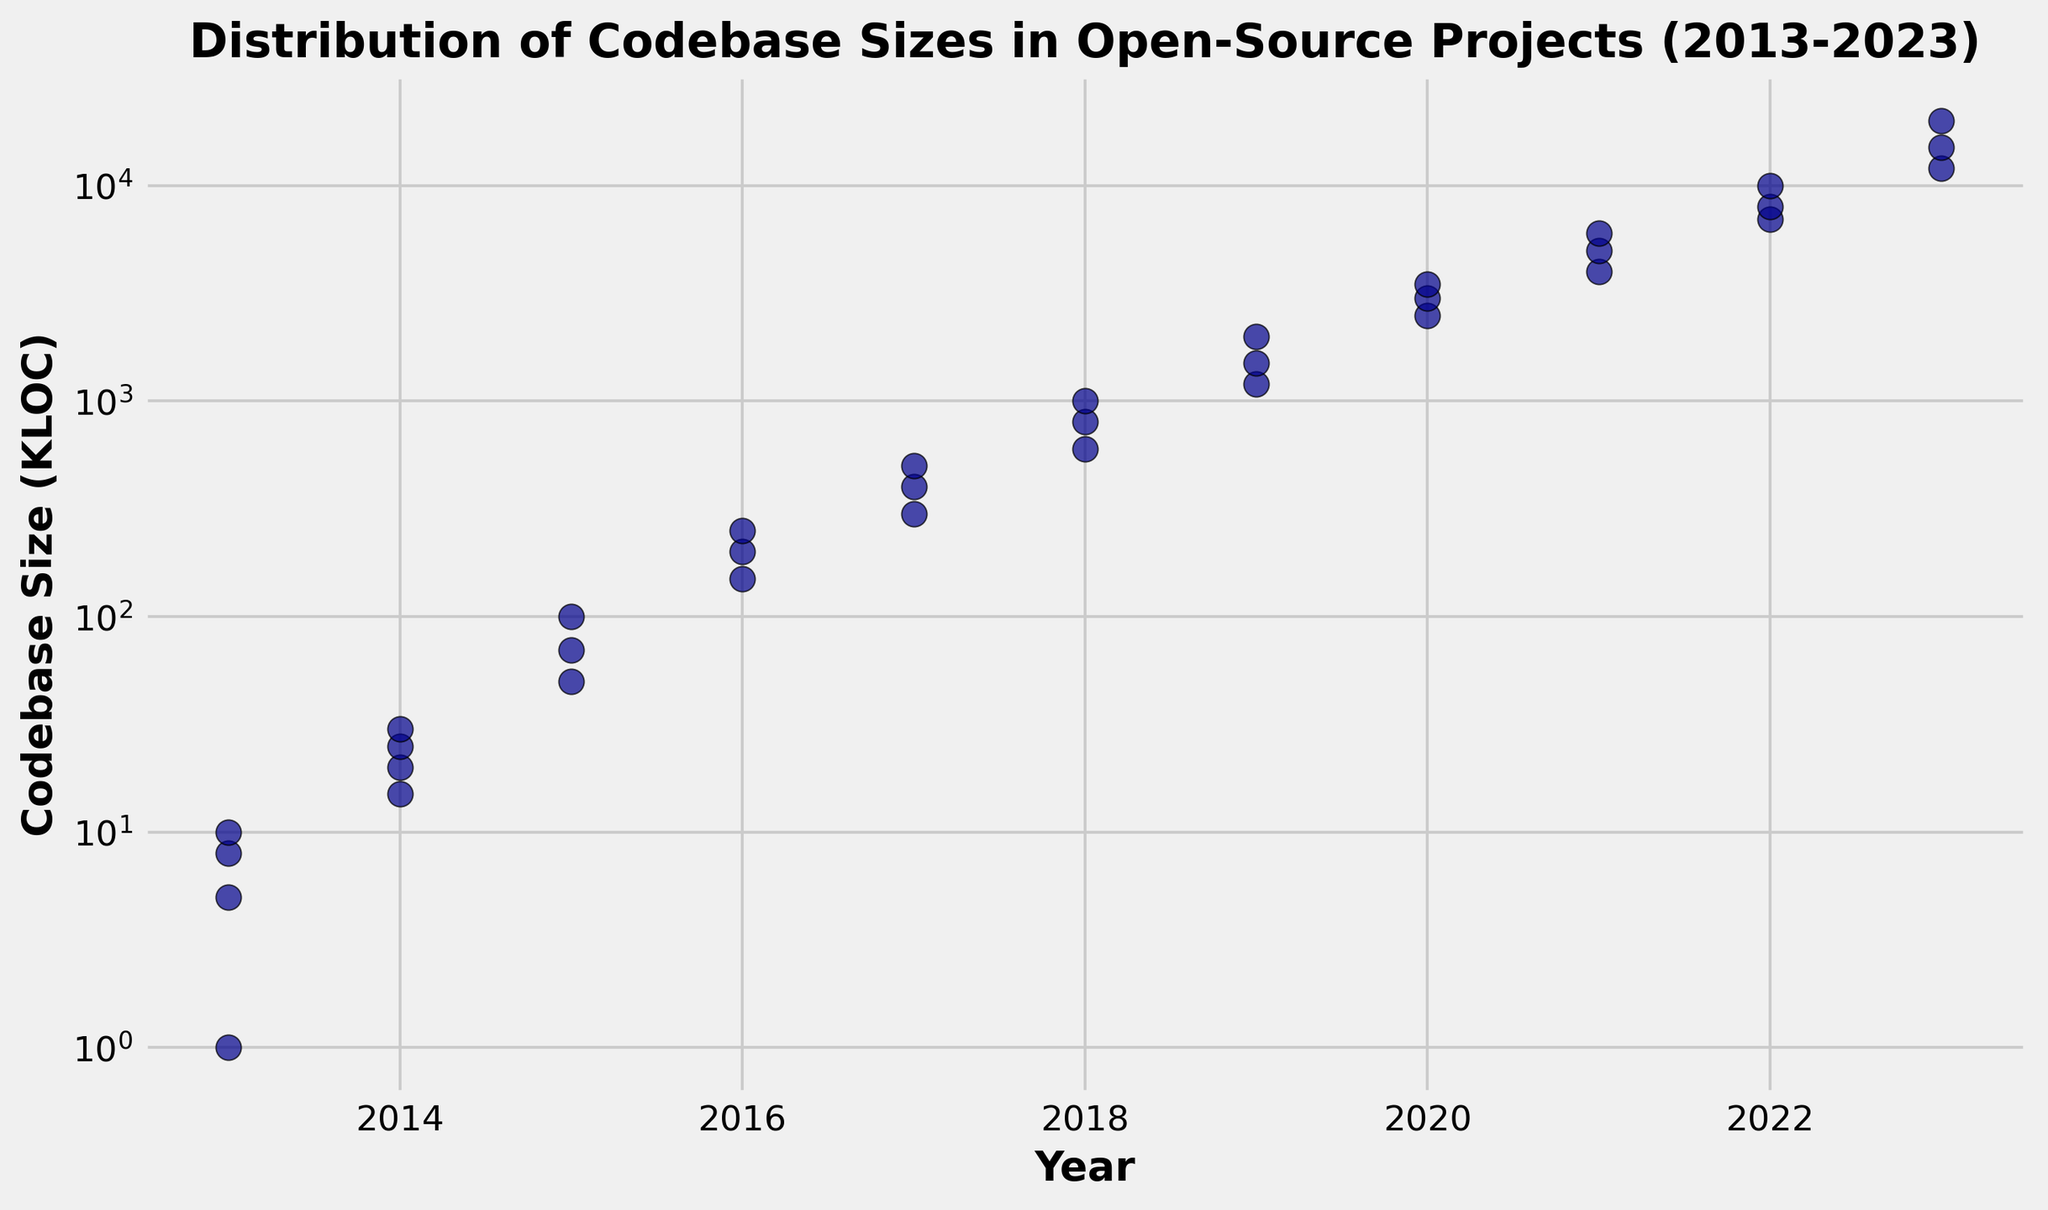What is the overall trend in the size of codebases from 2013 to 2023? The codebases are displayed on a log-scale y-axis from 2013 to 2023, showing an upward trend in size. In 2013, codebases are generally smaller, while they are significantly larger by 2023.
Answer: Increasing Which year has the largest codebase size, and approximately how large is it? Observing the year 2023, the largest codebase size reaches around 20,000 KLOC, as indicated by the highest point on the y-axis.
Answer: 2023; ~20,000 KLOC Between which two consecutive years did the smallest increase in maximum codebase size occur? By examining the log-scaled y-axis, the smallest visible increase between two consecutive years occurs between 2016 (250 KLOC) and 2017 (300 KLOC).
Answer: 2016 and 2017 Which year has the most dispersed codebase sizes (i.e., highest range)? The year 2015 shows codebase sizes ranging from 50 KLOC to 100 KLOC. Other years either have fewer data points or smaller ranges, indicating that 2015 has the most dispersed codebase sizes.
Answer: 2015 In terms of visual density, which year contains the highest concentration of codebase sizes? 2013 shows the highest concentration with data points closely clustered between 1 KLOC and 10 KLOC. Other years have fewer points dispersed over larger ranges.
Answer: 2013 How does the average codebase size in 2019 compare to that in 2017? In 2019, the sizes are 1200, 1500, and 2000 KLOC, averaging to (1200+1500+2000)/3=1566.67 KLOC. For 2017, the sizes are 300, 400, and 500 KLOC, averaging to (300+400+500)/3 = 400 KLOC. Comparing the two: 1566.67 KLOC (2019) is larger than 400 KLOC (2017).
Answer: 2019's average is larger Is the codebase size increasing steadily every year, or are there significant fluctuations? There is a general increasing trend, but there are fluctuations not every year sees a steady increase. Some years have large jumps, like from 2019 to 2020, while others have smaller increases, like from 2016 to 2017.
Answer: Fluctuations How frequently does the maximum codebase size double from the previous year? From a visual inspection of the log-scale, doubling is frequent initially and becomes less frequent in later years. Roughly seen in transitions from 2014 to 2015 (15 to 25), 2018 to 2019 (1000 to 2000), but not always every year.
Answer: Occasionally Which year saw the most significant jump in maximum codebase size? The largest visible jump in maximum codebase size occurs between 2022 (10,000 KLOC) and 2023 (20,000 KLOC), where the size doubles.
Answer: Between 2022 and 2023 